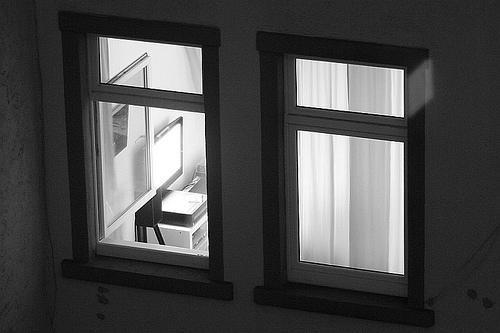How many windows are visible?
Give a very brief answer. 2. How many windows have curtains?
Give a very brief answer. 1. How many window panels do you see?
Give a very brief answer. 4. 